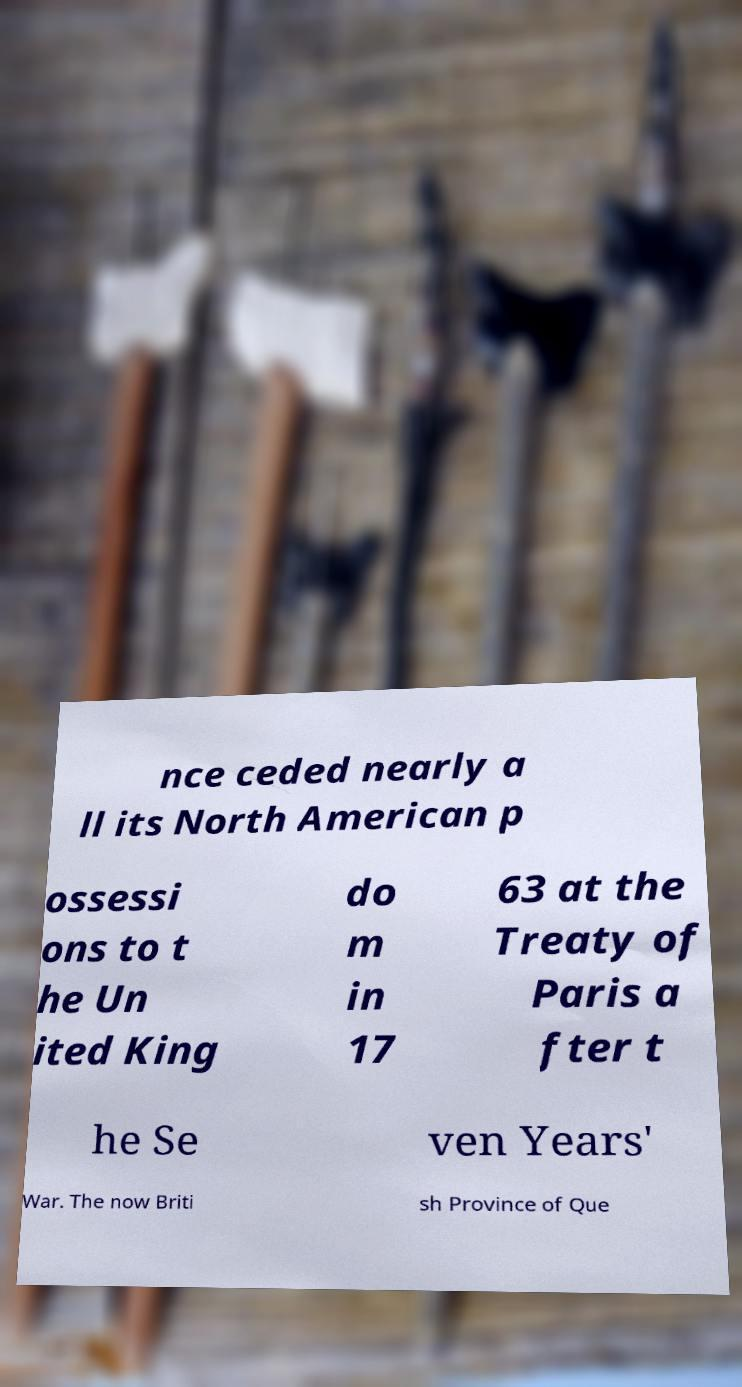Could you extract and type out the text from this image? nce ceded nearly a ll its North American p ossessi ons to t he Un ited King do m in 17 63 at the Treaty of Paris a fter t he Se ven Years' War. The now Briti sh Province of Que 